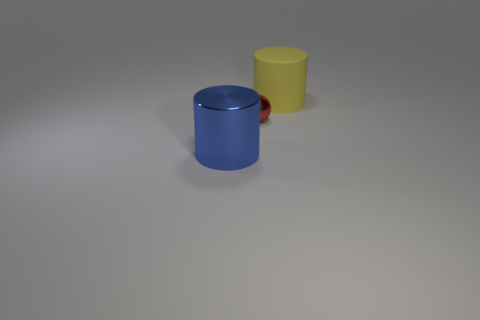Add 3 big red rubber balls. How many objects exist? 6 Subtract all tiny cyan cylinders. Subtract all blue metallic cylinders. How many objects are left? 2 Add 3 big yellow rubber objects. How many big yellow rubber objects are left? 4 Add 1 small red metallic balls. How many small red metallic balls exist? 2 Subtract 0 gray blocks. How many objects are left? 3 Subtract all cylinders. How many objects are left? 1 Subtract 1 cylinders. How many cylinders are left? 1 Subtract all yellow cylinders. Subtract all brown blocks. How many cylinders are left? 1 Subtract all blue blocks. How many brown cylinders are left? 0 